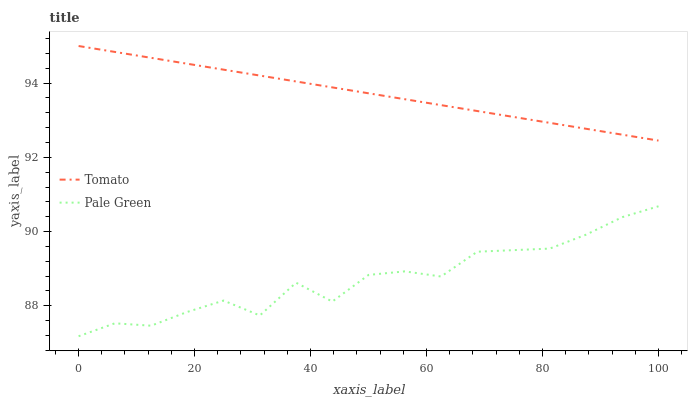Does Pale Green have the minimum area under the curve?
Answer yes or no. Yes. Does Tomato have the maximum area under the curve?
Answer yes or no. Yes. Does Pale Green have the maximum area under the curve?
Answer yes or no. No. Is Tomato the smoothest?
Answer yes or no. Yes. Is Pale Green the roughest?
Answer yes or no. Yes. Is Pale Green the smoothest?
Answer yes or no. No. Does Pale Green have the highest value?
Answer yes or no. No. Is Pale Green less than Tomato?
Answer yes or no. Yes. Is Tomato greater than Pale Green?
Answer yes or no. Yes. Does Pale Green intersect Tomato?
Answer yes or no. No. 